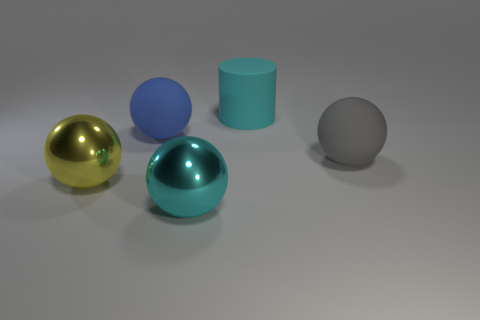Add 4 big cyan metallic spheres. How many objects exist? 9 Subtract all balls. How many objects are left? 1 Add 3 rubber balls. How many rubber balls are left? 5 Add 4 small shiny balls. How many small shiny balls exist? 4 Subtract 0 red spheres. How many objects are left? 5 Subtract all large blue spheres. Subtract all yellow spheres. How many objects are left? 3 